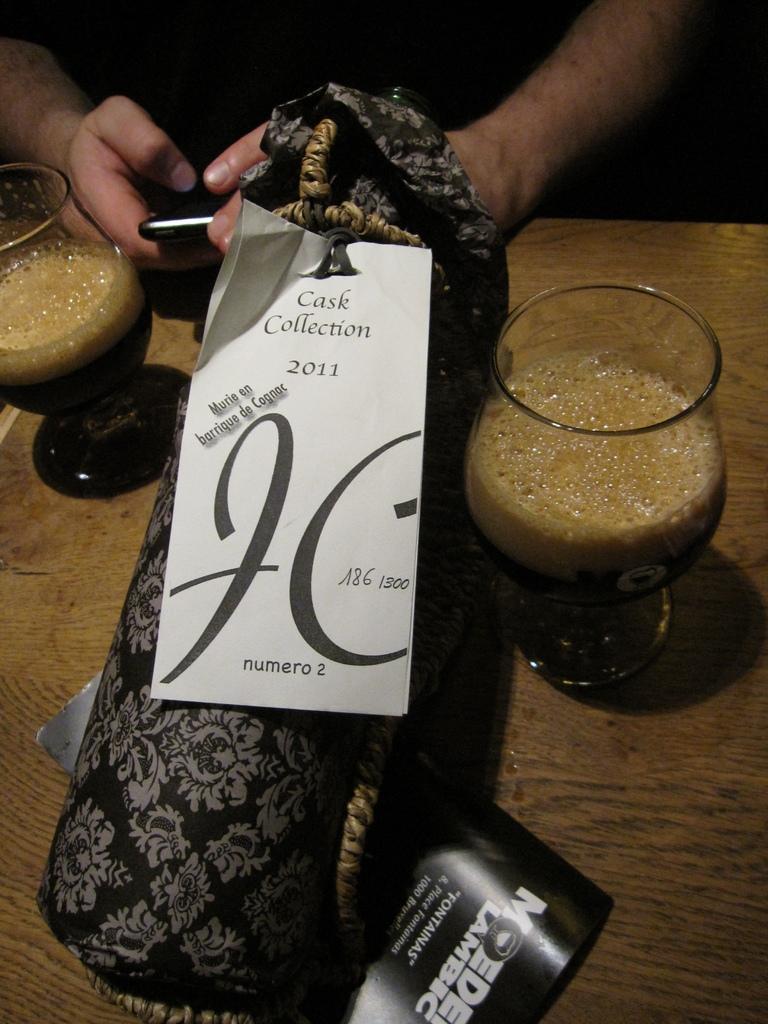In one or two sentences, can you explain what this image depicts? In the foreground of this picture we can see the glasses of drinks and some objects are placed on the top of the table and we can see the text on the papers. In the background we can see a person holding an object and seems to be sitting. 